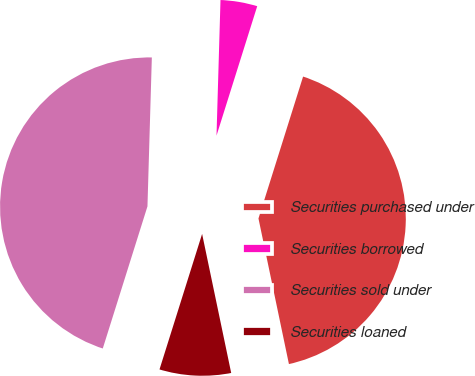Convert chart to OTSL. <chart><loc_0><loc_0><loc_500><loc_500><pie_chart><fcel>Securities purchased under<fcel>Securities borrowed<fcel>Securities sold under<fcel>Securities loaned<nl><fcel>41.87%<fcel>4.38%<fcel>45.62%<fcel>8.13%<nl></chart> 